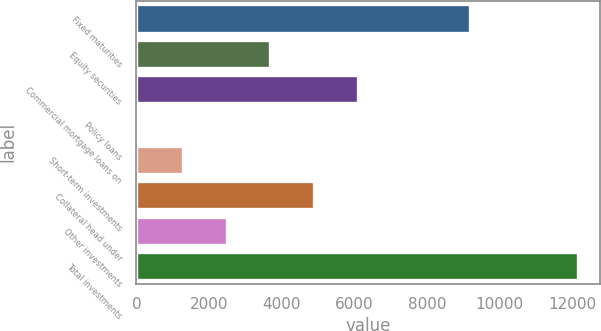Convert chart. <chart><loc_0><loc_0><loc_500><loc_500><bar_chart><fcel>Fixed maturities<fcel>Equity securities<fcel>Commercial mortgage loans on<fcel>Policy loans<fcel>Short-term investments<fcel>Collateral head under<fcel>Other investments<fcel>Total investments<nl><fcel>9178<fcel>3689.9<fcel>6106.5<fcel>65<fcel>1273.3<fcel>4898.2<fcel>2481.6<fcel>12148<nl></chart> 